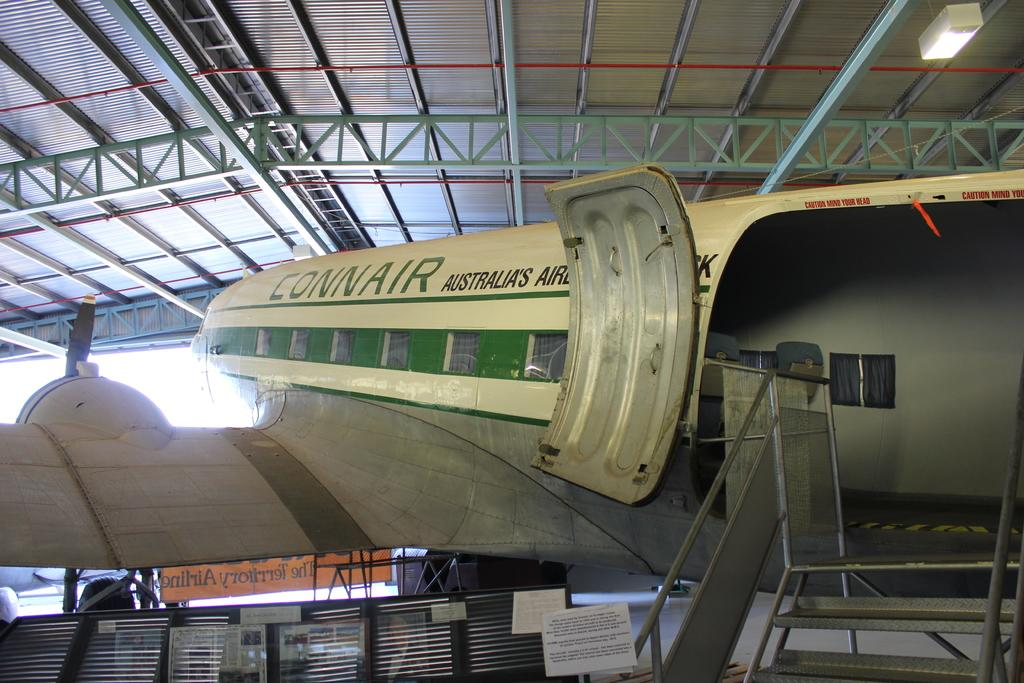<image>
Describe the image concisely. A Connair brand Australian aircraft has an open door. 